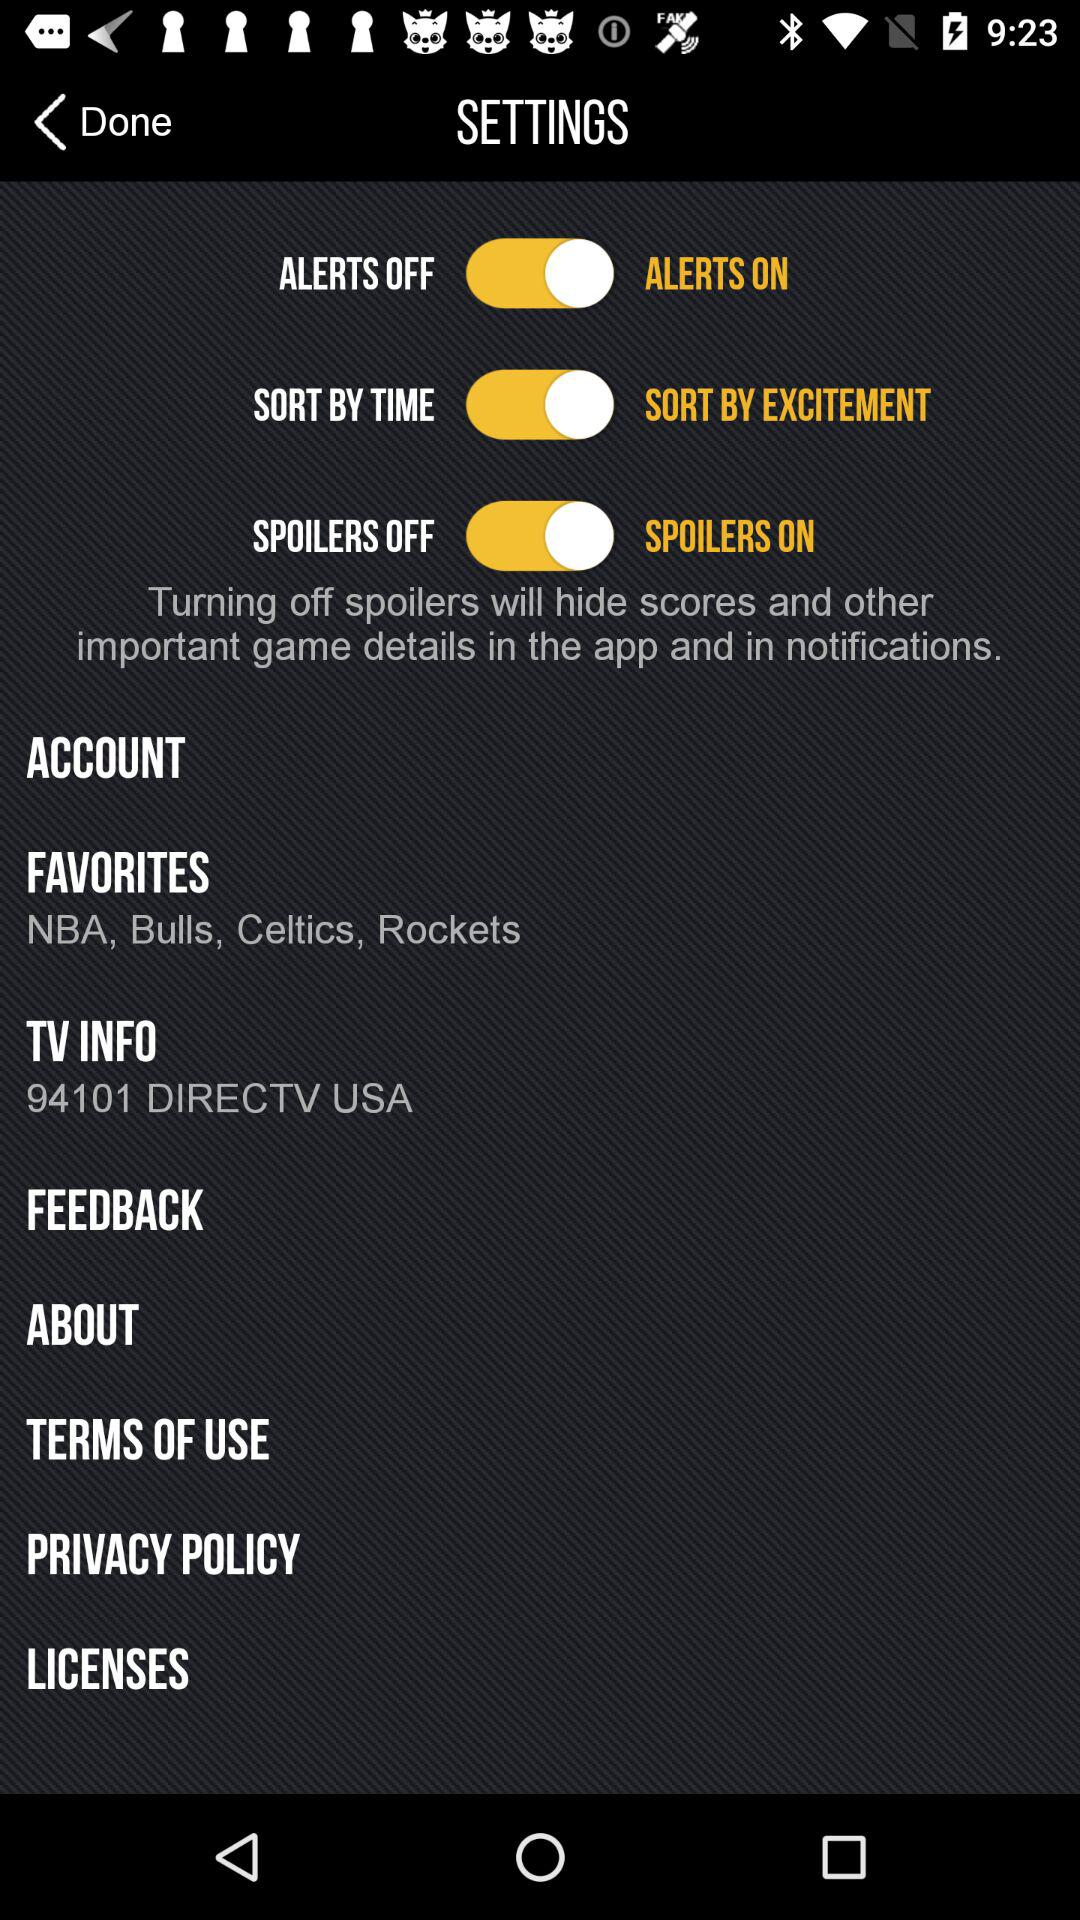What is the status of "SPOILERS"? The status is "on". 